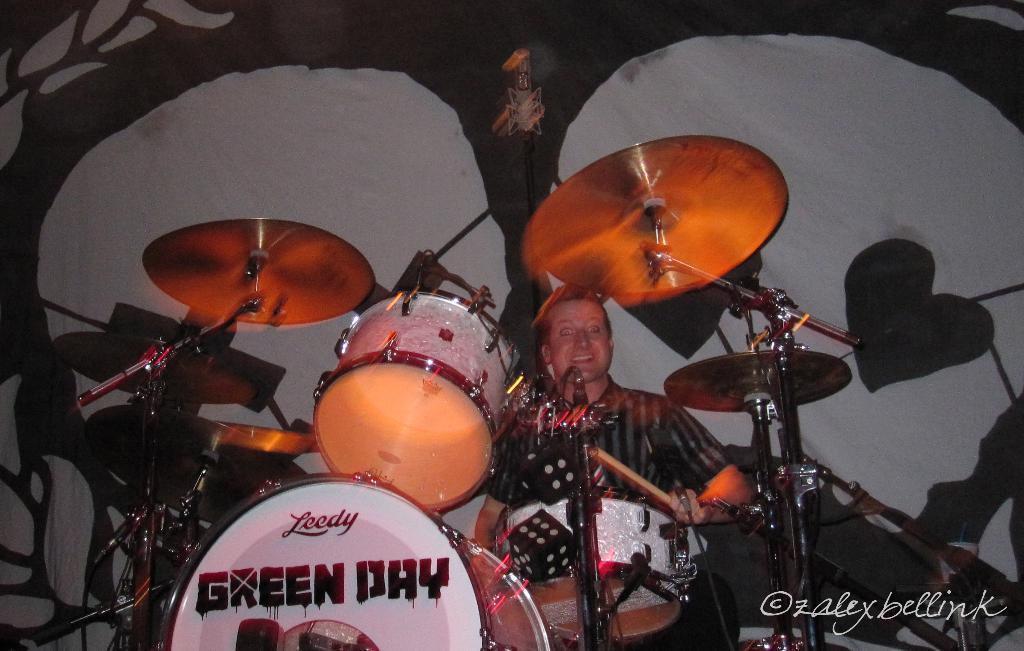Please provide a concise description of this image. In this picture I can see a person sitting, there are drums, cymbals with the cymbals stands, and in the background there is a cloth and there is a watermark on the image. 